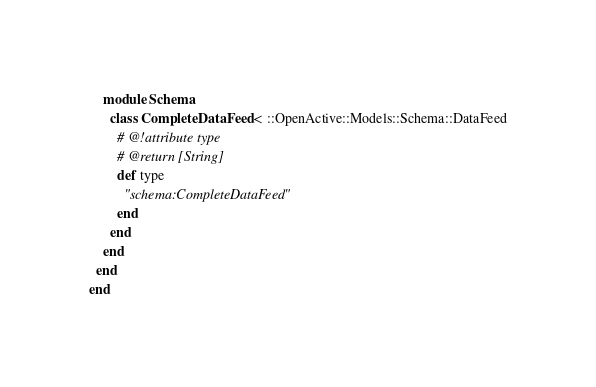Convert code to text. <code><loc_0><loc_0><loc_500><loc_500><_Ruby_>    module Schema
      class CompleteDataFeed < ::OpenActive::Models::Schema::DataFeed
        # @!attribute type
        # @return [String]
        def type
          "schema:CompleteDataFeed"
        end
      end
    end
  end
end
</code> 